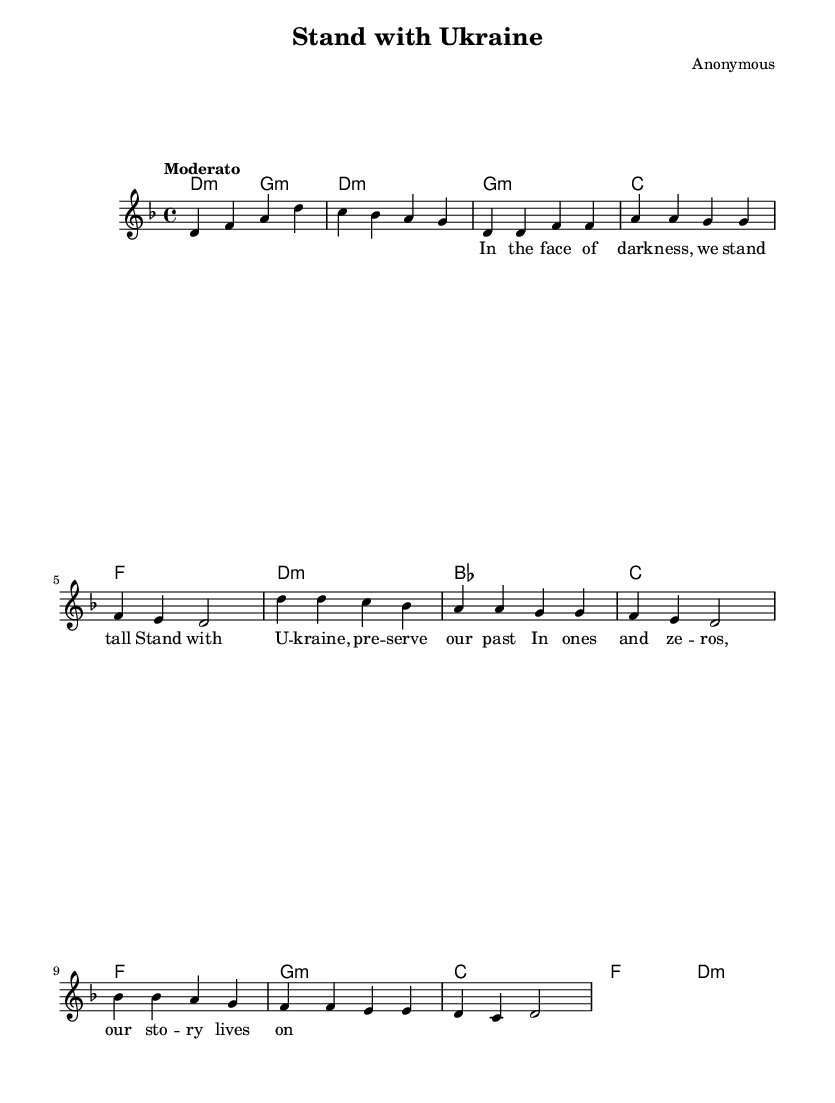What is the key signature of this music? The key signature indicates that the piece is in D minor, which has one flat (B flat) in its key signature. This can be determined by looking at the beginning of the score where the flatten sign for B is placed.
Answer: D minor What is the time signature of this music? The time signature is 4/4, found near the beginning of the score, indicating that there are four beats in each measure and the quarter note gets one beat.
Answer: 4/4 What is the tempo of the music? The tempo is marked as "Moderato," which suggests a moderate speed of performance. You can find this indication written above the staff in the score.
Answer: Moderato How many sections are in the song? The sheet music contains three distinct sections: Intro, Verse 1, and Chorus leading up to the Bridge. The division of sections can be identified through both lyrics and changes in melody block within the score layout.
Answer: Three What chord transitions occur in the chorus? In the chorus, the chord transitions are from D minor to B flat to C to F. By looking at the harmony section during the chorus, one can see these chords listed sequentially.
Answer: D minor, B flat, C, F What is the first lyric of the song? The first lyric presented in the score is "In the face of dark -- ness, we stand tall." The starting lyrics can be identified by looking for the first line of the text associated with the melody.
Answer: In the face of dark -- ness, we stand tall 